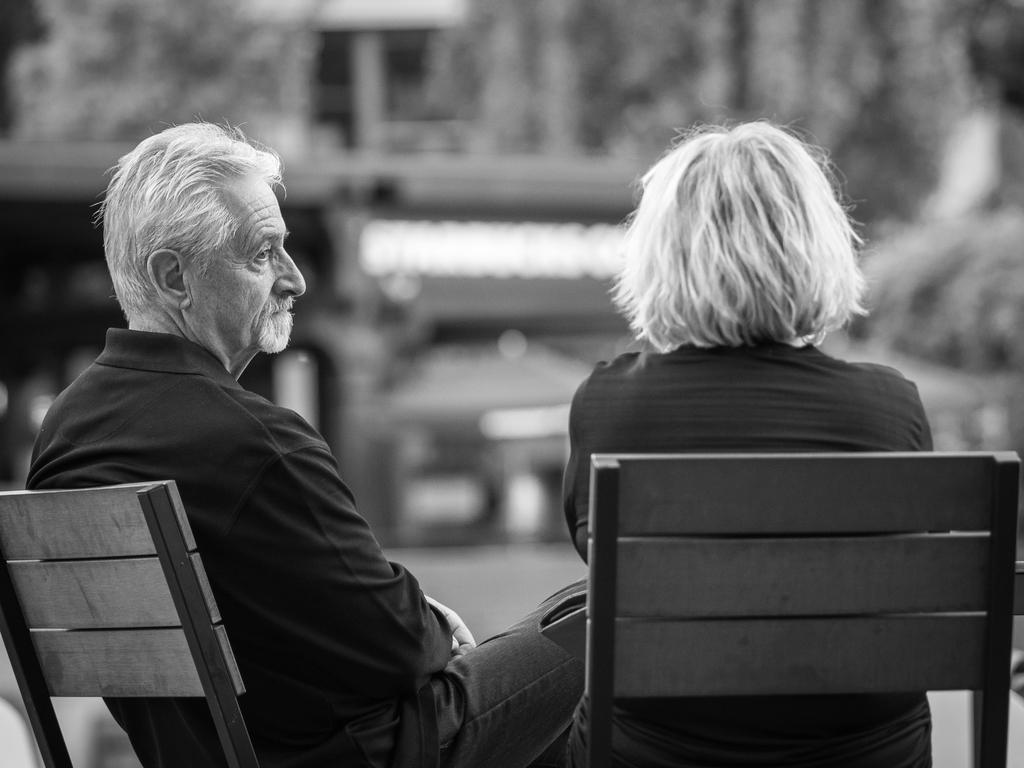How many people are present in the image? There are two people in the image. What are the people doing in the image? The two people are sitting on chairs. Can you describe the background of the image? The background of the image is blurry. What type of joke is the deer telling in the image? There is no deer present in the image, and therefore no joke can be observed. 